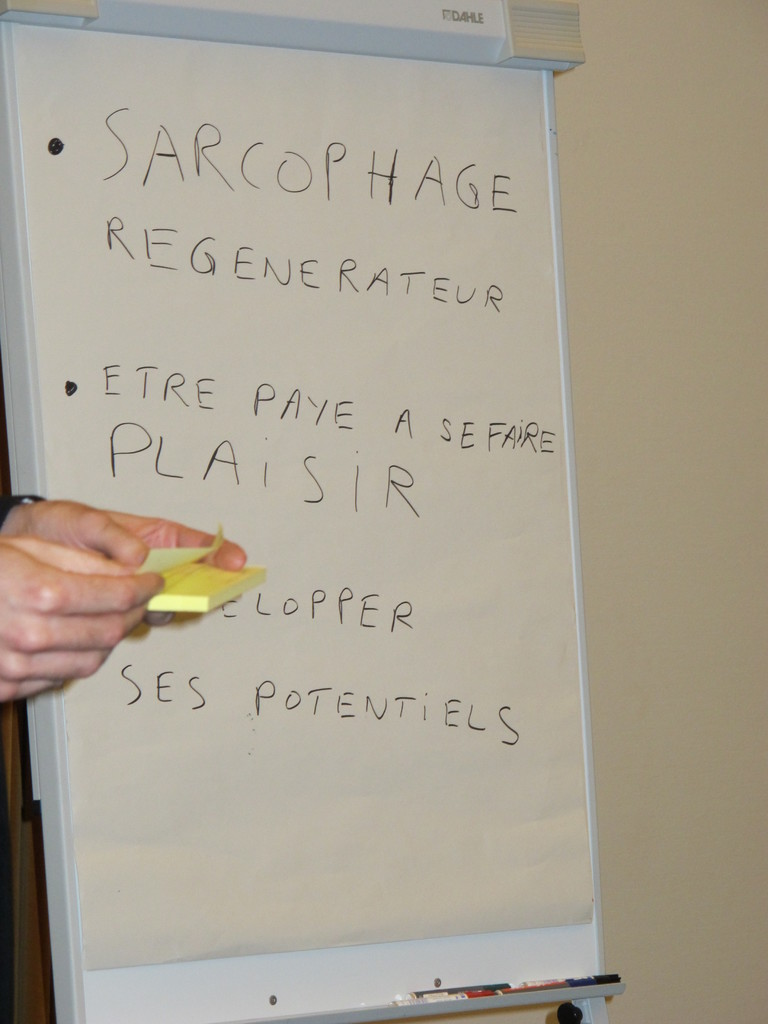How does the concept of 'ETRE PAYE A SE FAIRE PLAISIR' integrate with common professional practices? The phrase 'ETRE PAYE A SE FAIRE PLAISIR' which translates to 'Being paid to have fun' challenges traditional views on professional environments, emphasizing the importance of enjoyment and passion in work. It suggests a discourse on enhancing job satisfaction and employee motivation, potentially discussing innovative HR practices that align personal pleasures and professional success. 